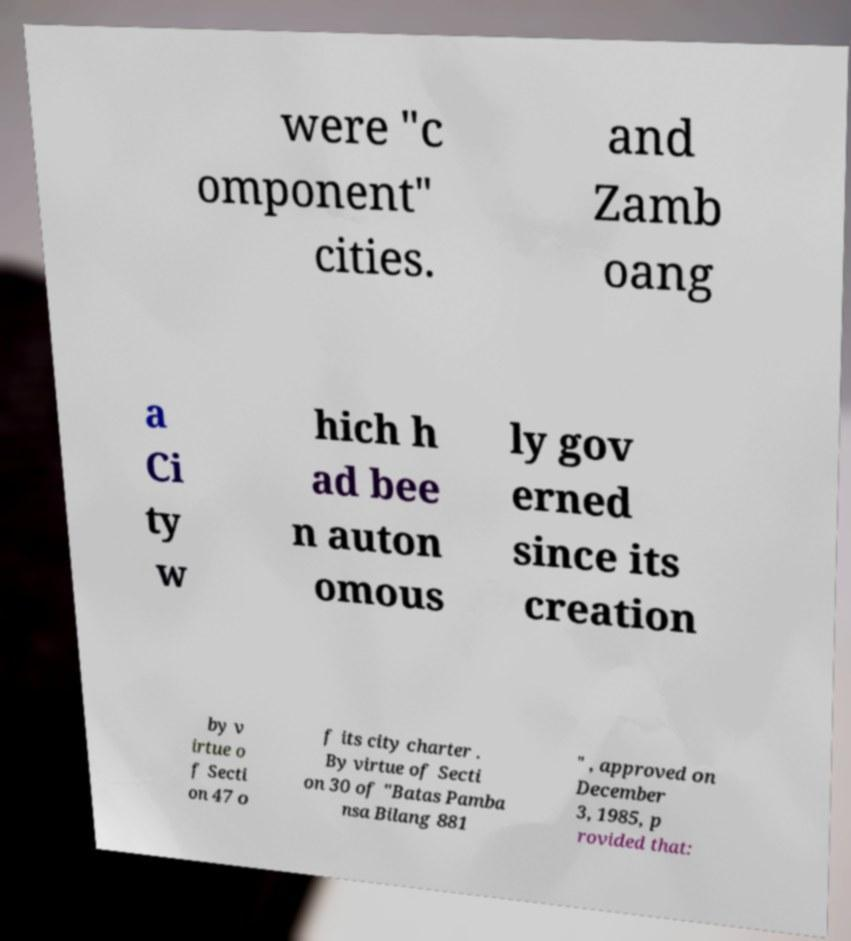There's text embedded in this image that I need extracted. Can you transcribe it verbatim? were "c omponent" cities. and Zamb oang a Ci ty w hich h ad bee n auton omous ly gov erned since its creation by v irtue o f Secti on 47 o f its city charter . By virtue of Secti on 30 of "Batas Pamba nsa Bilang 881 " , approved on December 3, 1985, p rovided that: 